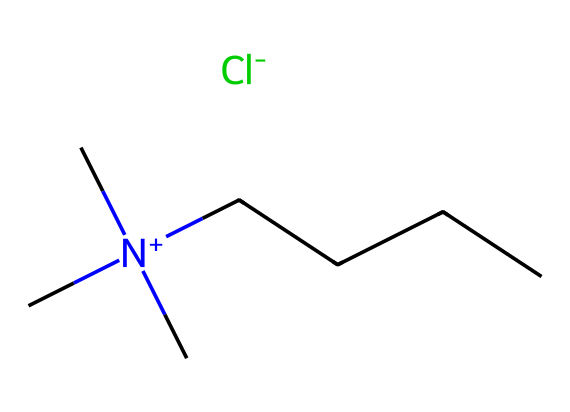How many carbon atoms are in the structure? By analyzing the SMILES representation, count the 'C' symbols, which represent carbon atoms. There are a total of 6 carbon atoms visible when accounting for the branch and the straight chain.
Answer: 6 What type of counterion is present in this ionic liquid? The SMILES notation indicates a chloride ion (represented by [Cl-]) as the counterion accompanying the positively charged component, which is typical for ionic liquids.
Answer: chloride What is the charge on the nitrogen atom? In the SMILES representation, the nitrogen atom is denoted by [N+], indicating it has a positive charge due to the association with three carbon chains.
Answer: positive What functional group is indicated by the "N+"? The representation shows that nitrogen is bonded to three methyl groups (C[N+](C)(C)), indicating it is a quaternary ammonium compound, which is often found in ionic liquids.
Answer: quaternary ammonium What is the primary purpose of including ionic liquids in cleaning products? Ionic liquids are often used in cleaning products due to their ability to dissolve a wide range of materials and their low volatility, contributing to effective cleaning action without leaving harmful residues.
Answer: cleaning agent 